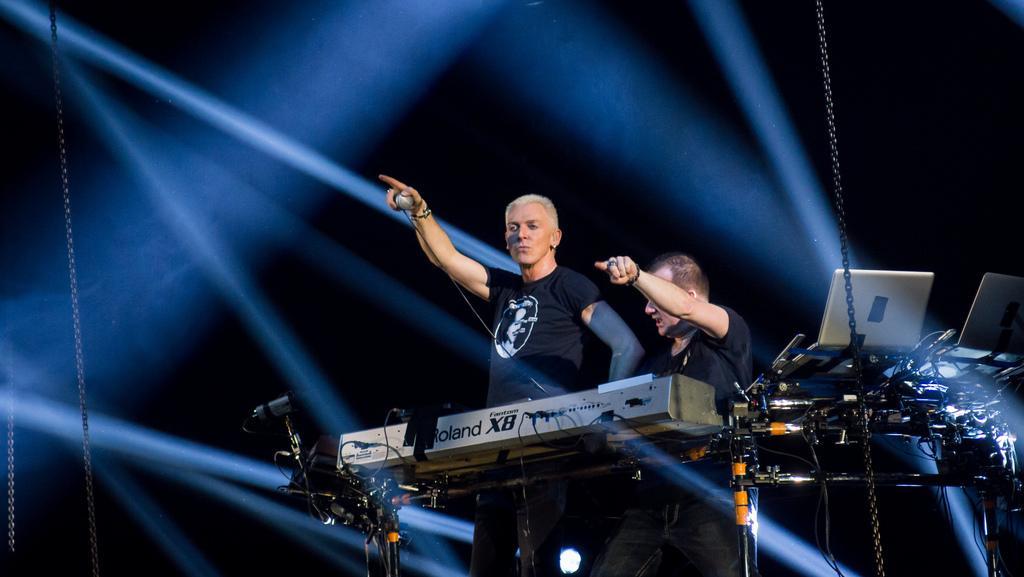In one or two sentences, can you explain what this image depicts? Here a man is standing and pointing his finger. He wore a black color t-shirt. Beside him there is a man, he wore a black color t-shirt also. 